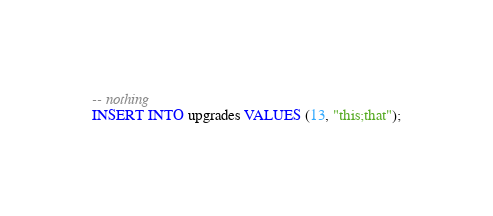Convert code to text. <code><loc_0><loc_0><loc_500><loc_500><_SQL_>-- nothing
INSERT INTO upgrades VALUES (13, "this;that");</code> 